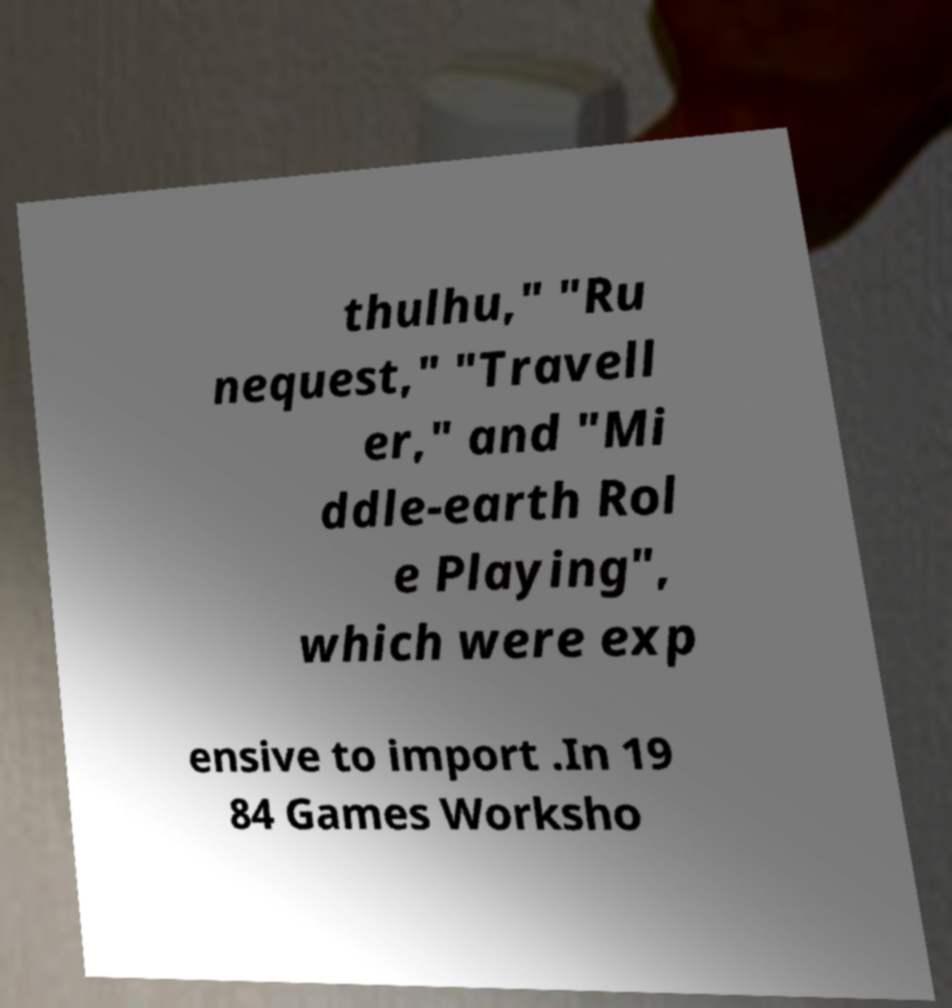For documentation purposes, I need the text within this image transcribed. Could you provide that? thulhu," "Ru nequest," "Travell er," and "Mi ddle-earth Rol e Playing", which were exp ensive to import .In 19 84 Games Worksho 